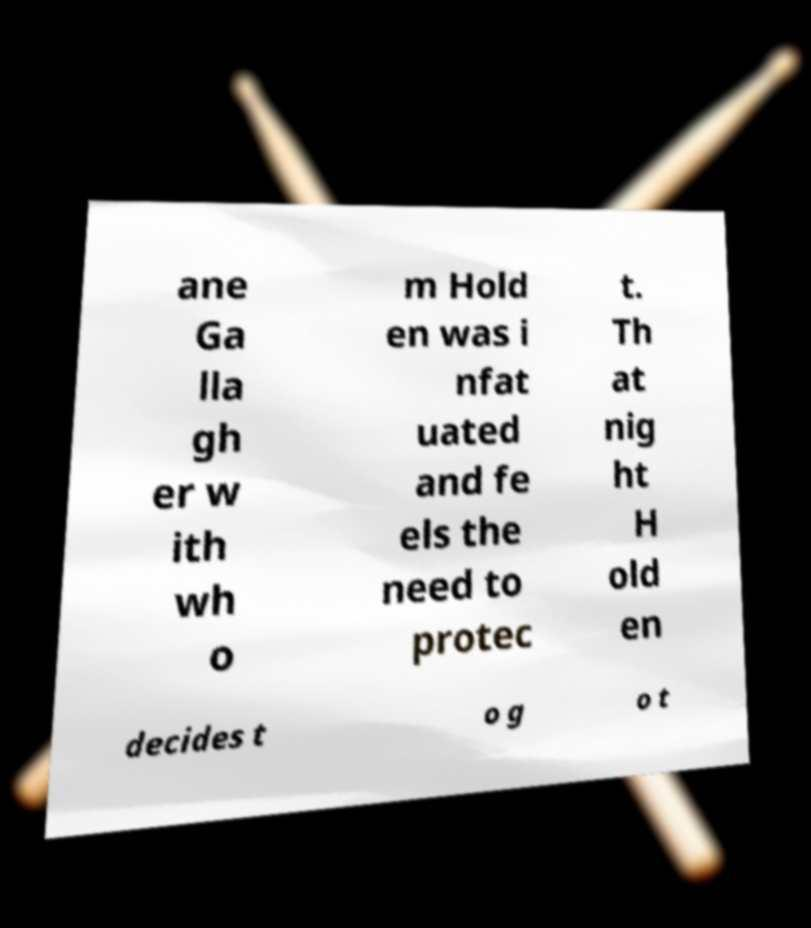Could you assist in decoding the text presented in this image and type it out clearly? ane Ga lla gh er w ith wh o m Hold en was i nfat uated and fe els the need to protec t. Th at nig ht H old en decides t o g o t 